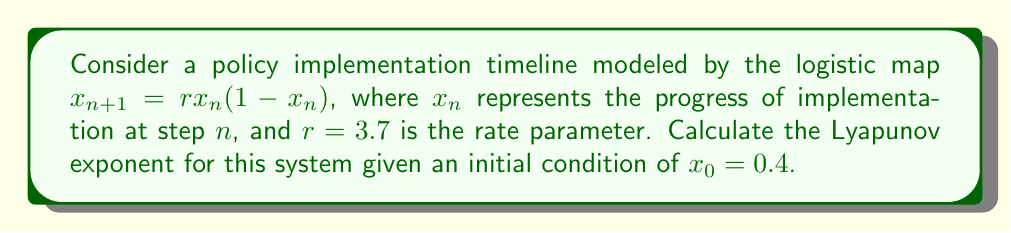Can you answer this question? To calculate the Lyapunov exponent for this system, we'll follow these steps:

1) The Lyapunov exponent $\lambda$ for a 1D map is given by:

   $$\lambda = \lim_{N \to \infty} \frac{1}{N} \sum_{n=0}^{N-1} \ln |f'(x_n)|$$

   where $f'(x)$ is the derivative of the map function.

2) For the logistic map $f(x) = rx(1-x)$, the derivative is:

   $$f'(x) = r(1-2x)$$

3) We need to iterate the map and sum the logarithms of the absolute values of $f'(x_n)$:

   $x_0 = 0.4$
   $x_1 = 3.7 * 0.4 * (1-0.4) = 0.888$
   $x_2 = 3.7 * 0.888 * (1-0.888) = 0.3684$
   ...

4) For each $x_n$, we calculate $\ln |f'(x_n)|$:

   $\ln |f'(x_0)| = \ln |3.7(1-2*0.4)| = \ln 0.74 = -0.3011$
   $\ln |f'(x_1)| = \ln |3.7(1-2*0.888)| = \ln 2.5836 = 0.9492$
   $\ln |f'(x_2)| = \ln |3.7(1-2*0.3684)| = \ln 0.9768 = -0.0235$
   ...

5) We continue this process for a large number of iterations (e.g., N=1000), sum the results, and divide by N.

6) Using a computer to perform these calculations, we find:

   $$\lambda \approx 0.3574$$

This positive Lyapunov exponent indicates chaotic behavior in the policy implementation timeline.
Answer: $\lambda \approx 0.3574$ 